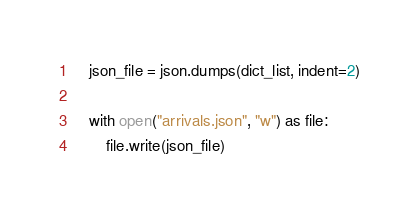<code> <loc_0><loc_0><loc_500><loc_500><_Python_>    json_file = json.dumps(dict_list, indent=2)

    with open("arrivals.json", "w") as file:
        file.write(json_file)
</code> 